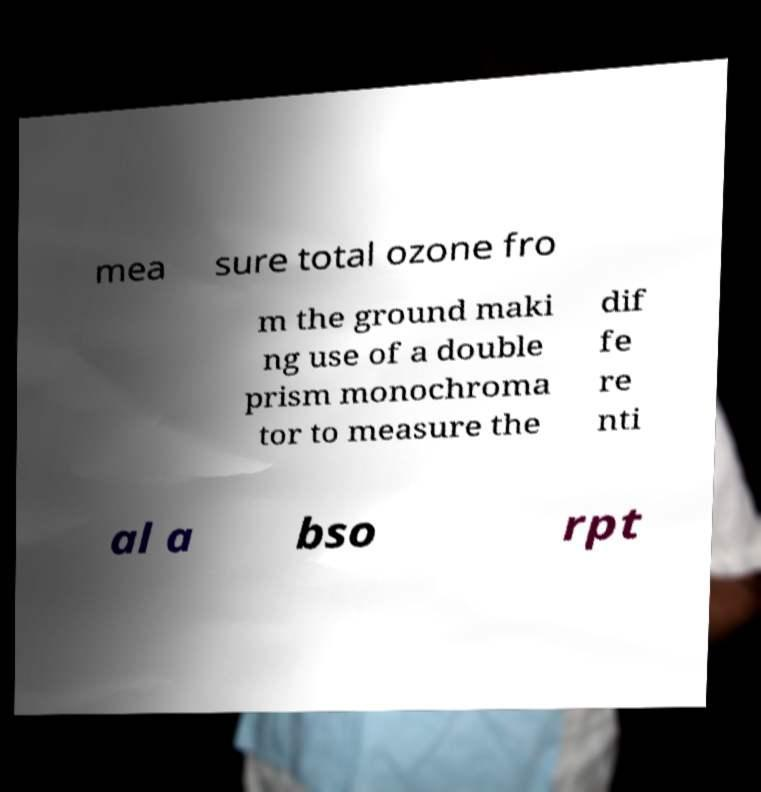What messages or text are displayed in this image? I need them in a readable, typed format. mea sure total ozone fro m the ground maki ng use of a double prism monochroma tor to measure the dif fe re nti al a bso rpt 